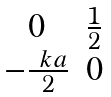Convert formula to latex. <formula><loc_0><loc_0><loc_500><loc_500>\begin{matrix} 0 & \frac { 1 } { 2 } \\ - \frac { \ k a } { 2 } & 0 \end{matrix}</formula> 